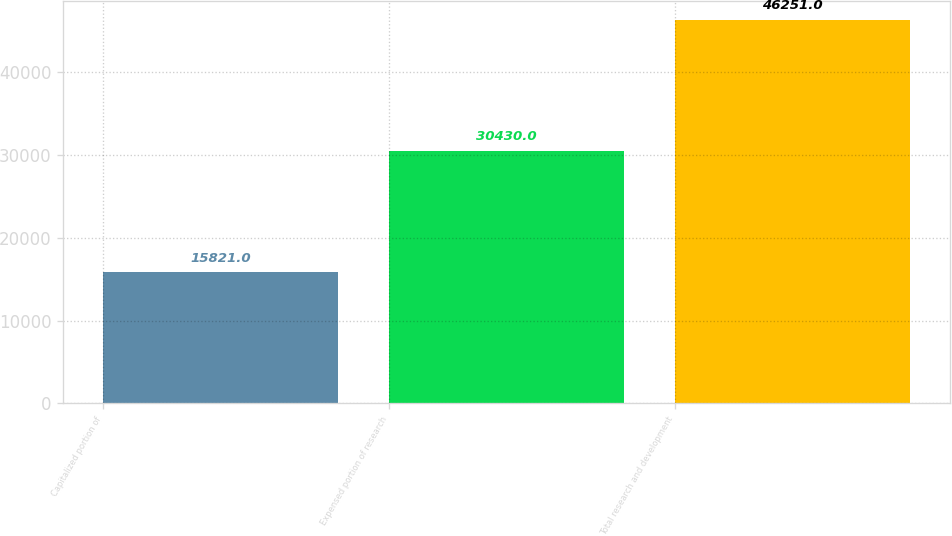Convert chart. <chart><loc_0><loc_0><loc_500><loc_500><bar_chart><fcel>Capitalized portion of<fcel>Expensed portion of research<fcel>Total research and development<nl><fcel>15821<fcel>30430<fcel>46251<nl></chart> 